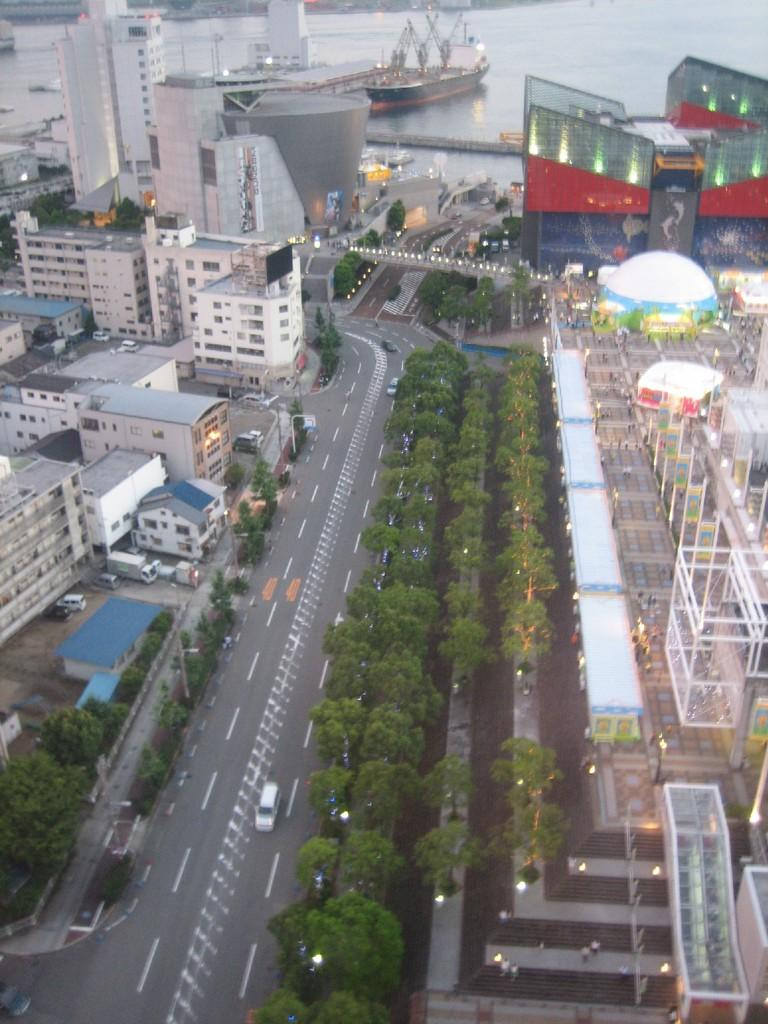What type of vehicles can be seen in the image? There are vehicles on the road in the image, but the specific type is not mentioned. What is the primary setting for the vehicles in the image? The vehicles are on the road. What else can be seen in the water besides the ships? The provided facts do not mention anything else in the water besides the ships. What type of structures are visible in the image? There are buildings in the image. What color is the marble sofa in the image? There is no mention of a sofa or marble in the image, so this question cannot be answered. 